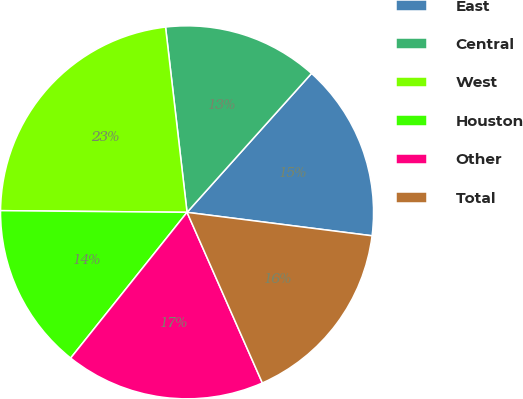Convert chart to OTSL. <chart><loc_0><loc_0><loc_500><loc_500><pie_chart><fcel>East<fcel>Central<fcel>West<fcel>Houston<fcel>Other<fcel>Total<nl><fcel>15.38%<fcel>13.47%<fcel>23.02%<fcel>14.42%<fcel>17.34%<fcel>16.38%<nl></chart> 